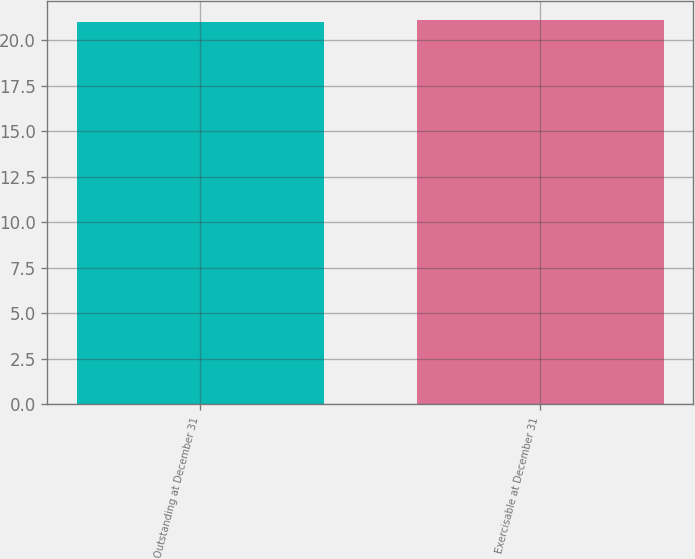Convert chart to OTSL. <chart><loc_0><loc_0><loc_500><loc_500><bar_chart><fcel>Outstanding at December 31<fcel>Exercisable at December 31<nl><fcel>21<fcel>21.1<nl></chart> 